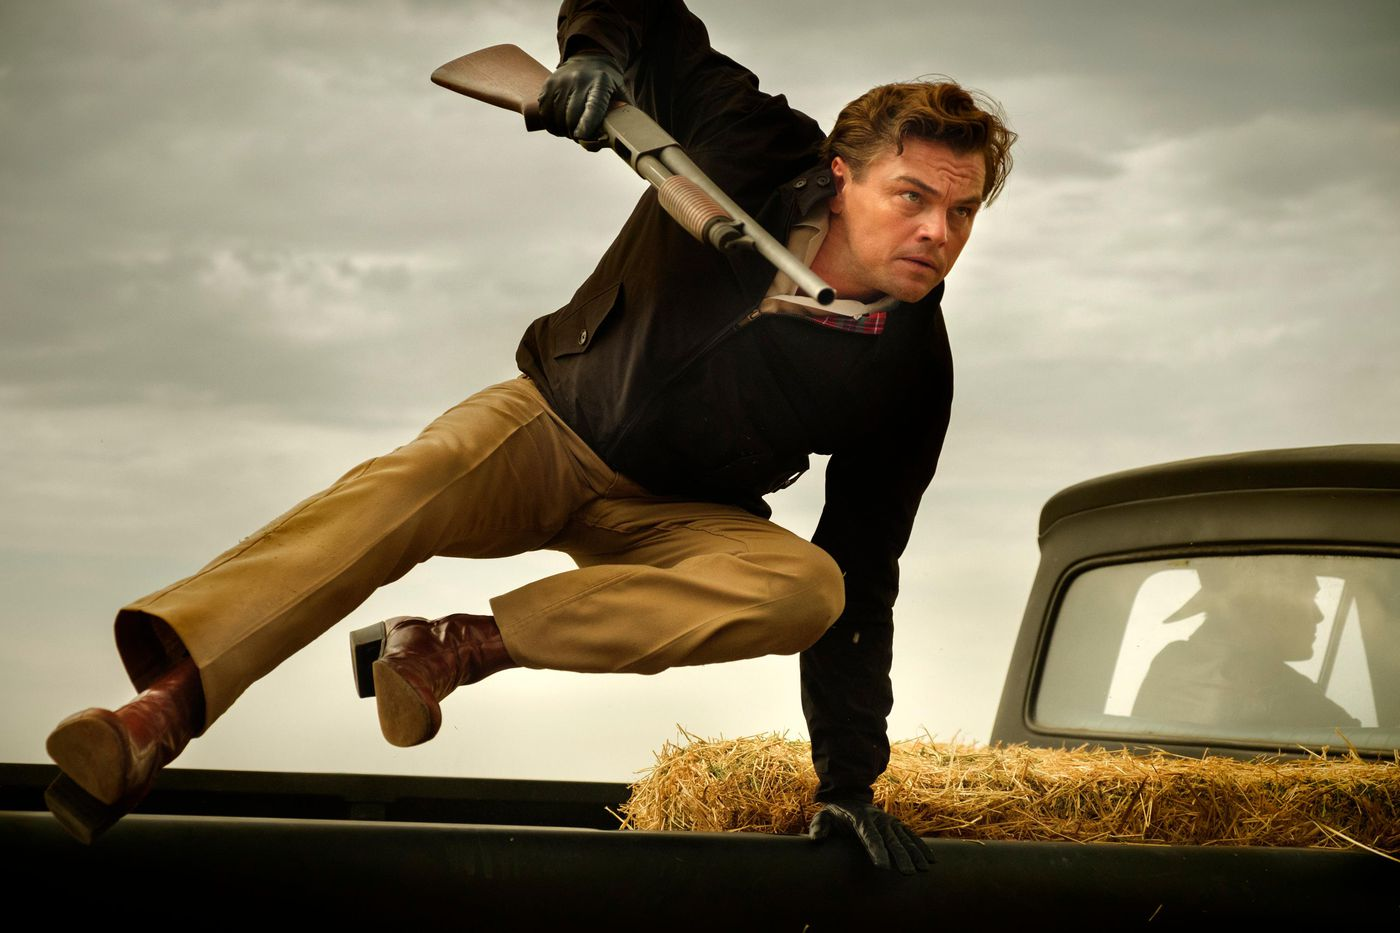Write a detailed description of the given image. In this dynamic image, we see a man, dressed in a black jacket, a red shirt, and tan pants, mid-action as he leaps over the hood of a vintage car, holding a shotgun. The man's intense expression complements his physical agility, suggesting a scene full of action and urgency. The vintage car beneath him is dusted with hay, indicating a rural or outdoor setting. The cloudy sky in the background adds a dramatic tension to the atmosphere, enhancing the overall intensity of the scene. 